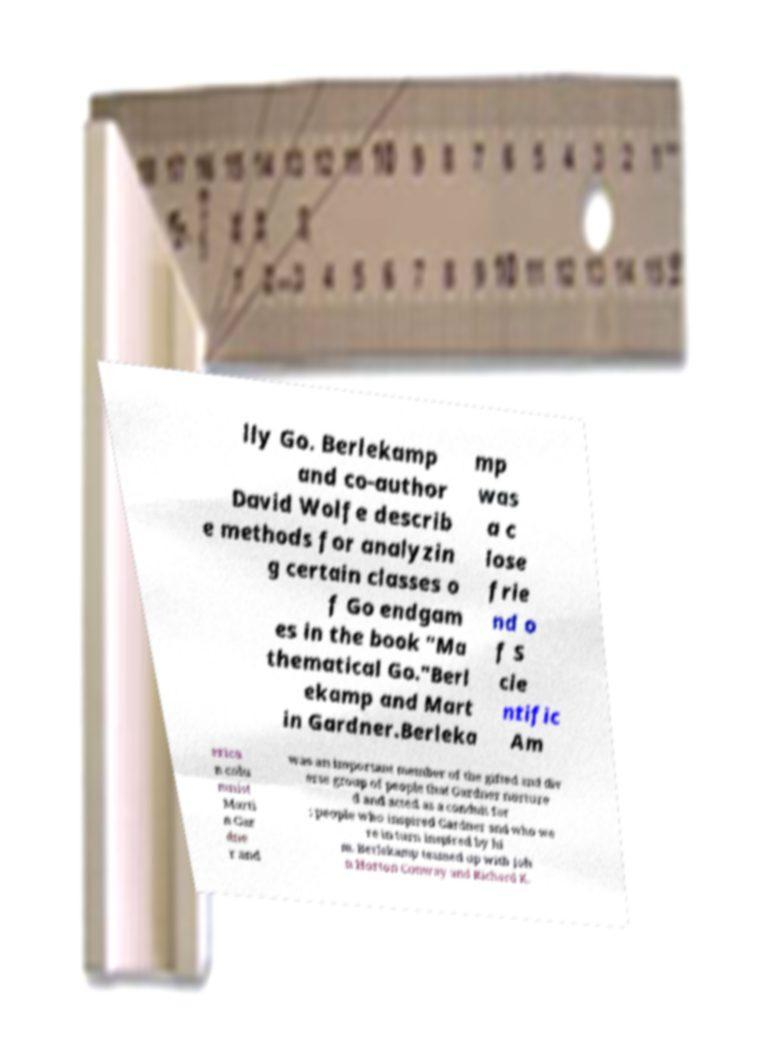Can you accurately transcribe the text from the provided image for me? lly Go. Berlekamp and co-author David Wolfe describ e methods for analyzin g certain classes o f Go endgam es in the book "Ma thematical Go."Berl ekamp and Mart in Gardner.Berleka mp was a c lose frie nd o f S cie ntific Am erica n colu mnist Marti n Gar dne r and was an important member of the gifted and div erse group of people that Gardner nurture d and acted as a conduit for ; people who inspired Gardner and who we re in turn inspired by hi m. Berlekamp teamed up with Joh n Horton Conway and Richard K. 